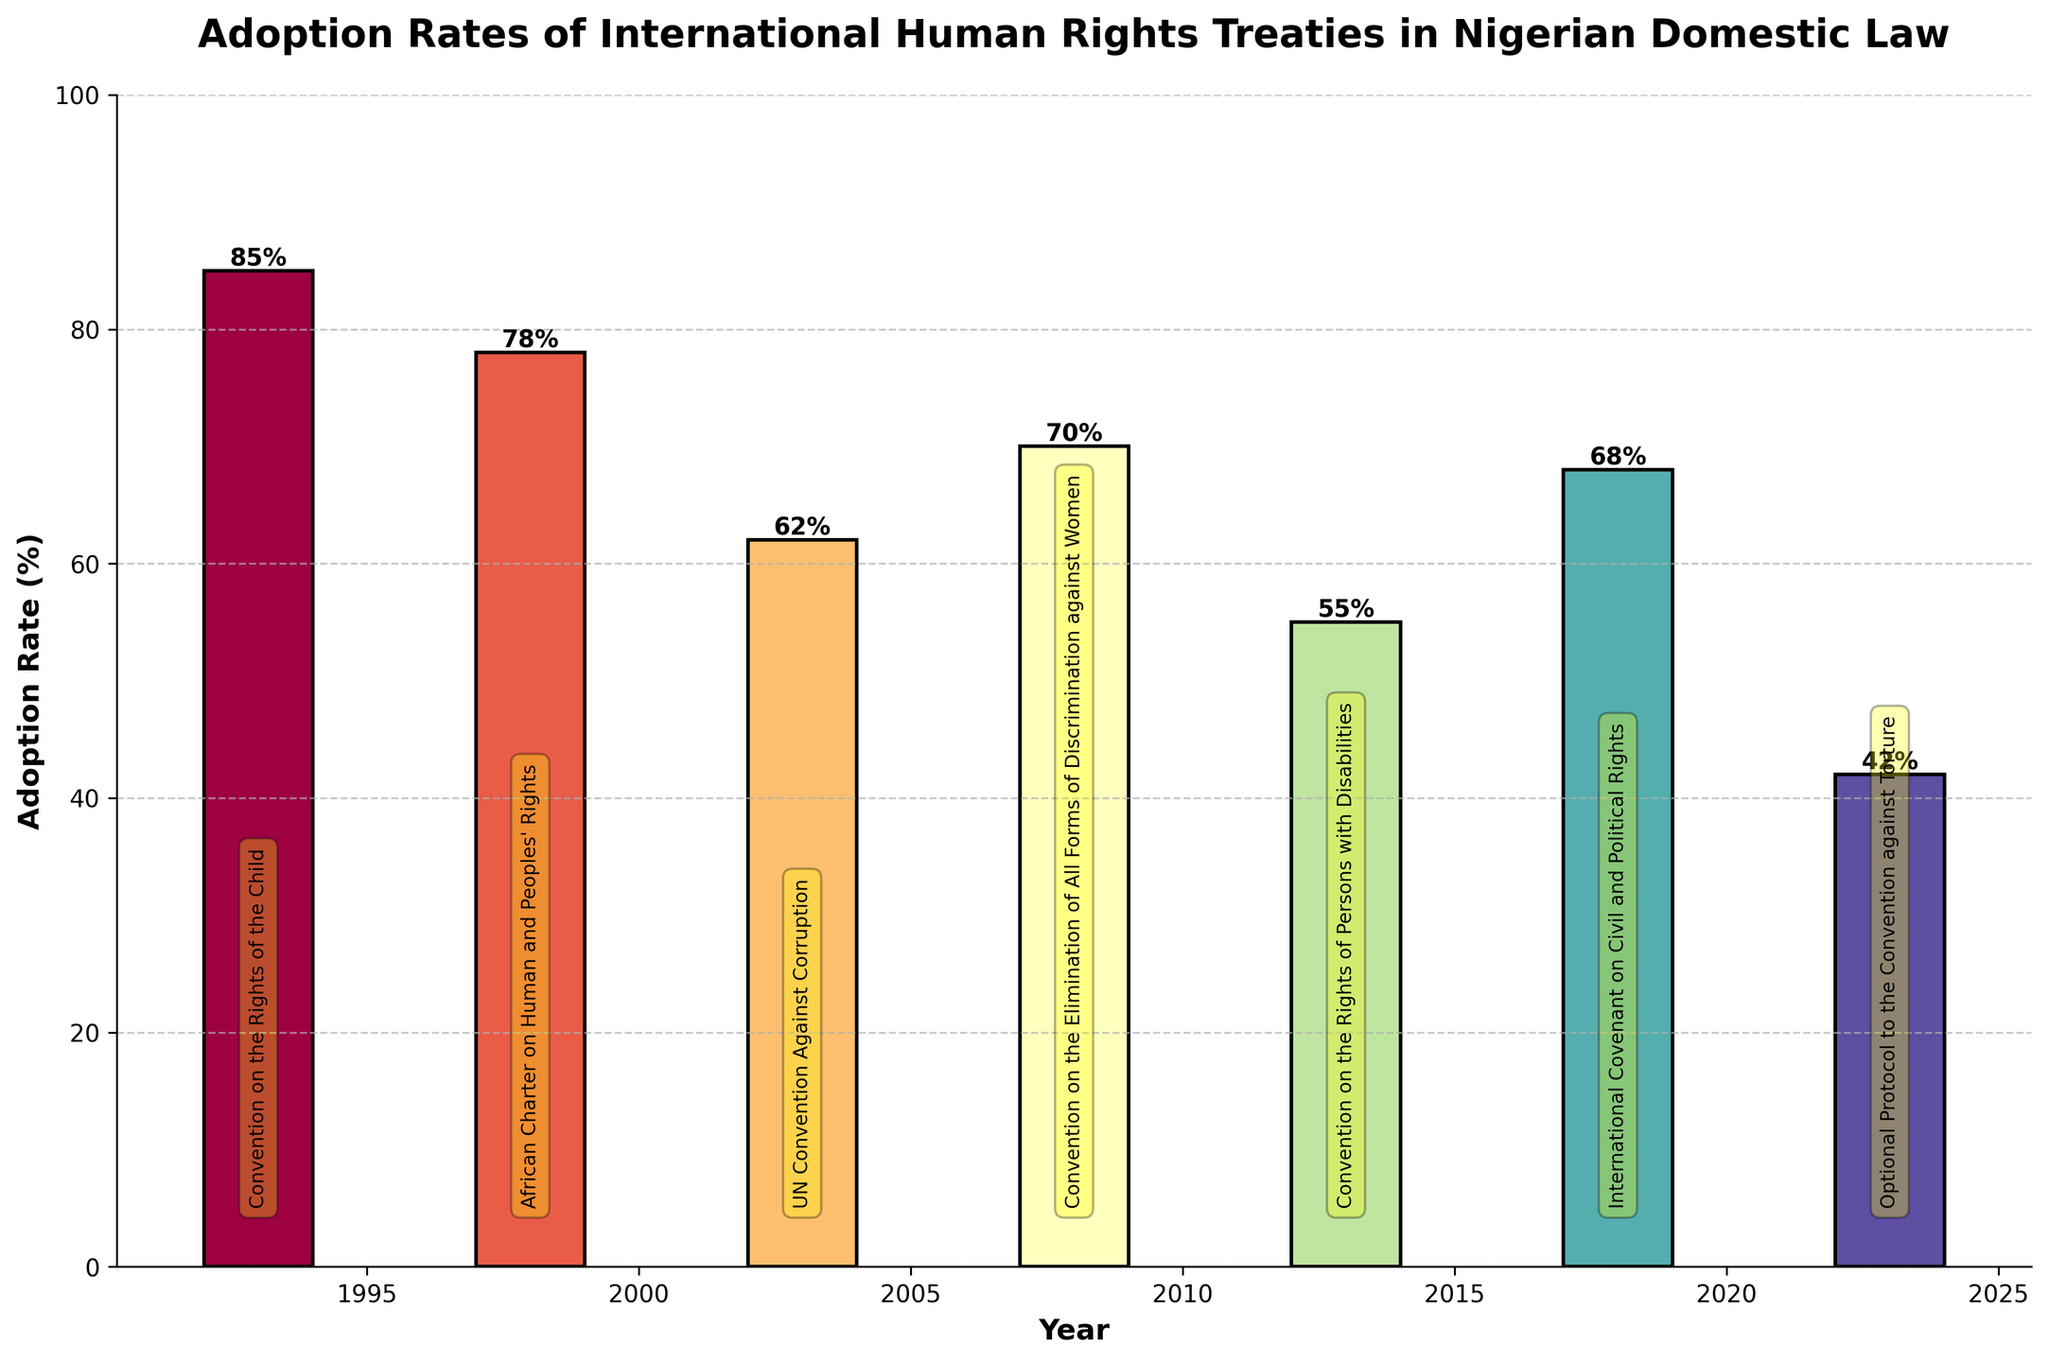Which treaty has the highest adoption rate? The bar corresponding to the year 1993 (Convention on the Rights of the Child) is the tallest, which means it represents the highest adoption rate.
Answer: Convention on the Rights of the Child Which treaty has the lowest adoption rate? The bar corresponding to the year 2023 (Optional Protocol to the Convention against Torture) is the shortest, making it the lowest adoption rate.
Answer: Optional Protocol to the Convention against Torture How many treaties have an adoption rate above 70%? The bars for the Convention on the Rights of the Child (1993) and the African Charter on Human and Peoples' Rights (1998) reach above the 70% mark. This means two treaties exceed 70%.
Answer: 2 What is the difference in adoption rates between the Convention on the Rights of the Child and the Optional Protocol to the Convention against Torture? The adoption rate for the Convention on the Rights of the Child is 85%, and for the Optional Protocol to the Convention against Torture, it is 42%. The difference is 85% - 42% = 43%.
Answer: 43% Which treaty adopted in the 2000s has the highest adoption rate? Among the treaties in the 2000s, the highest bar corresponds to 2008, which is the Convention on the Elimination of All Forms of Discrimination against Women with a 70% adoption rate.
Answer: Convention on the Elimination of All Forms of Discrimination against Women Is there an overall trend in adoption rates over the three decades? Observing the heights of the bars over the years shows no consistent increase or decrease trend. The rates fluctuate over the years, with high rates in early years (1993, 1998) and a dip noticeable in 2023.
Answer: No consistent trend What is the average adoption rate of the treaties listed? Adding the adoption rates (85 + 78 + 62 + 70 + 55 + 68 + 42) gives 460. There are seven treaties, so the average is 460 / 7 = 65.7%.
Answer: 65.7% Which year had the highest adoption rate, and which year had the lowest? The highest bar corresponds to 1993 (Convention on the Rights of the Child) with 85%, and the lowest bar corresponds to 2023 (Optional Protocol to the Convention against Torture) with 42%.
Answer: 1993 and 2023 